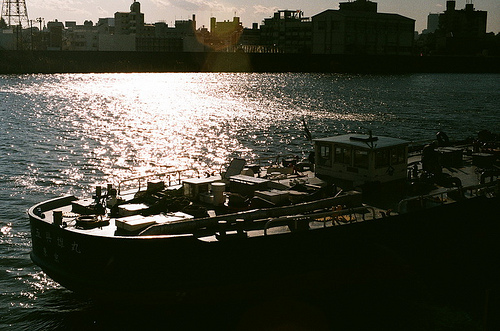Which place is it? The photo appears to be taken at a river or near a water body, though the exact location isn't specified. 